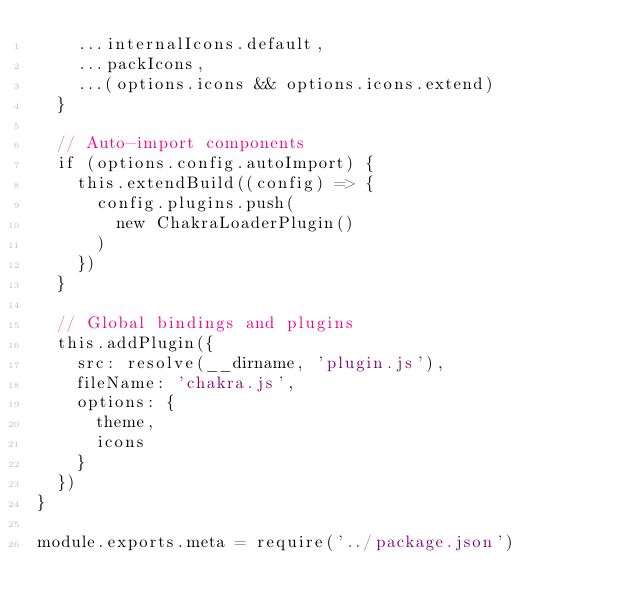<code> <loc_0><loc_0><loc_500><loc_500><_JavaScript_>    ...internalIcons.default,
    ...packIcons,
    ...(options.icons && options.icons.extend)
  }

  // Auto-import components
  if (options.config.autoImport) {
    this.extendBuild((config) => {
      config.plugins.push(
        new ChakraLoaderPlugin()
      )
    })
  }

  // Global bindings and plugins
  this.addPlugin({
    src: resolve(__dirname, 'plugin.js'),
    fileName: 'chakra.js',
    options: {
      theme,
      icons
    }
  })
}

module.exports.meta = require('../package.json')
</code> 